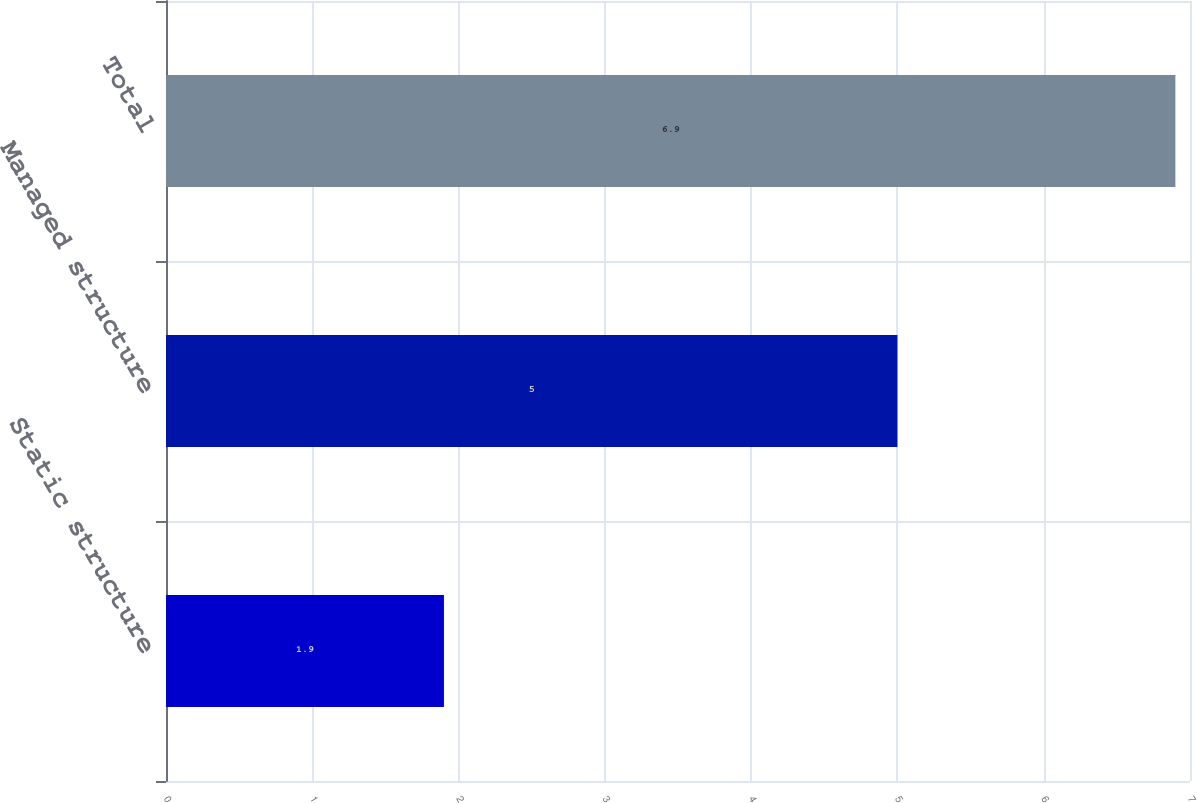<chart> <loc_0><loc_0><loc_500><loc_500><bar_chart><fcel>Static structure<fcel>Managed structure<fcel>Total<nl><fcel>1.9<fcel>5<fcel>6.9<nl></chart> 